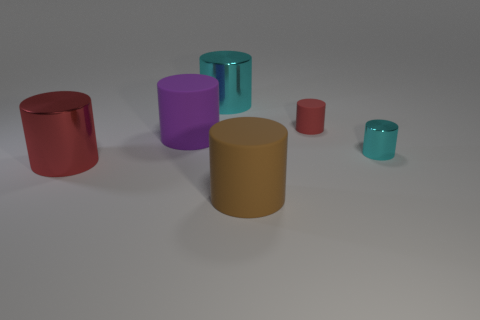The tiny metallic thing that is to the right of the red cylinder behind the large purple cylinder is what color?
Offer a very short reply. Cyan. Are there any other tiny cylinders of the same color as the small rubber cylinder?
Give a very brief answer. No. There is a red cylinder to the left of the rubber cylinder in front of the metallic cylinder that is on the left side of the big purple thing; what is its size?
Give a very brief answer. Large. Do the purple thing and the cyan metallic object that is on the left side of the big brown rubber object have the same shape?
Give a very brief answer. Yes. What number of other objects are there of the same size as the brown rubber object?
Make the answer very short. 3. There is a rubber cylinder right of the brown cylinder; how big is it?
Your answer should be very brief. Small. What number of large red cylinders are made of the same material as the large cyan cylinder?
Offer a very short reply. 1. Do the cyan shiny object in front of the large cyan cylinder and the red rubber object have the same shape?
Provide a succinct answer. Yes. There is another metal cylinder that is the same color as the tiny shiny cylinder; what size is it?
Offer a very short reply. Large. What is the material of the large purple thing?
Provide a short and direct response. Rubber. 